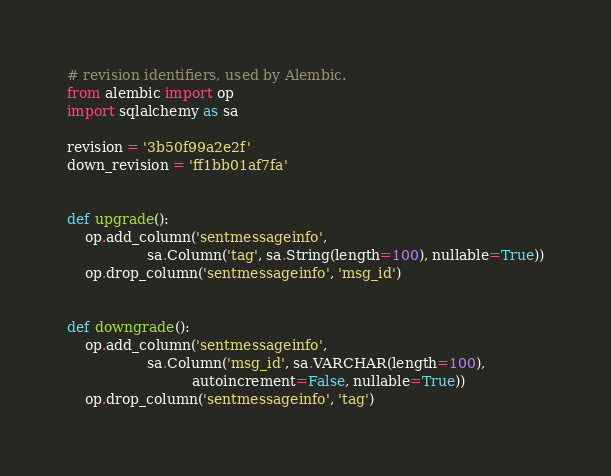Convert code to text. <code><loc_0><loc_0><loc_500><loc_500><_Python_># revision identifiers, used by Alembic.
from alembic import op
import sqlalchemy as sa

revision = '3b50f99a2e2f'
down_revision = 'ff1bb01af7fa'


def upgrade():
    op.add_column('sentmessageinfo',
                  sa.Column('tag', sa.String(length=100), nullable=True))
    op.drop_column('sentmessageinfo', 'msg_id')


def downgrade():
    op.add_column('sentmessageinfo',
                  sa.Column('msg_id', sa.VARCHAR(length=100),
                            autoincrement=False, nullable=True))
    op.drop_column('sentmessageinfo', 'tag')
</code> 